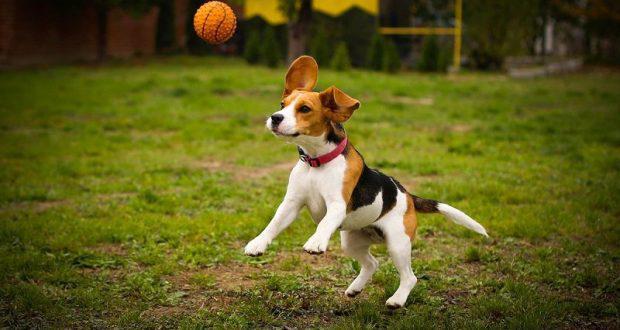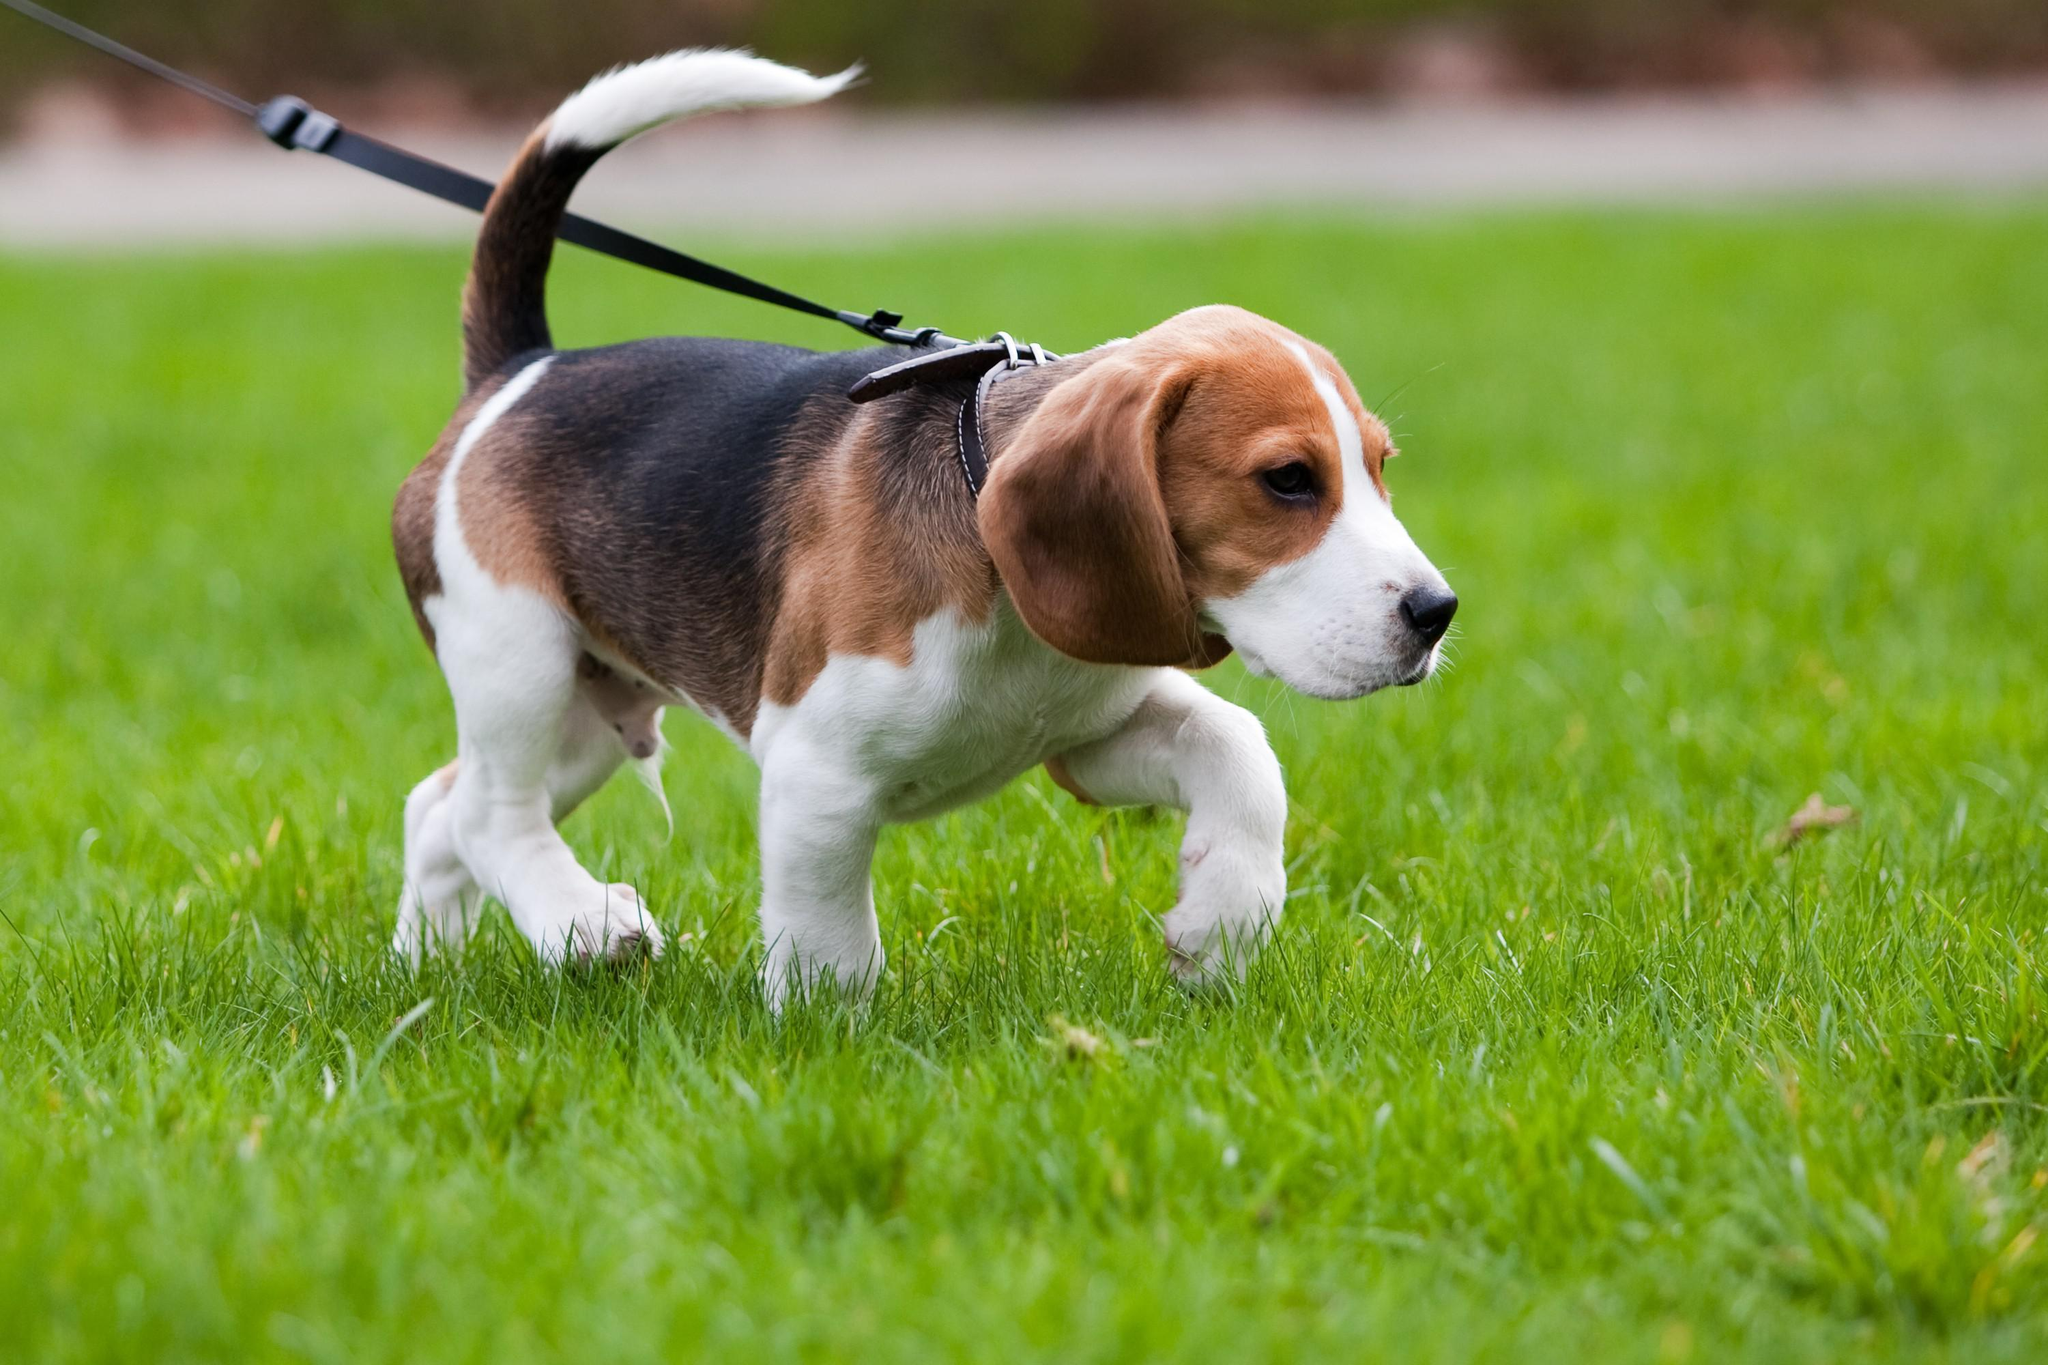The first image is the image on the left, the second image is the image on the right. Considering the images on both sides, is "The dog in the right image is on a leash." valid? Answer yes or no. Yes. 